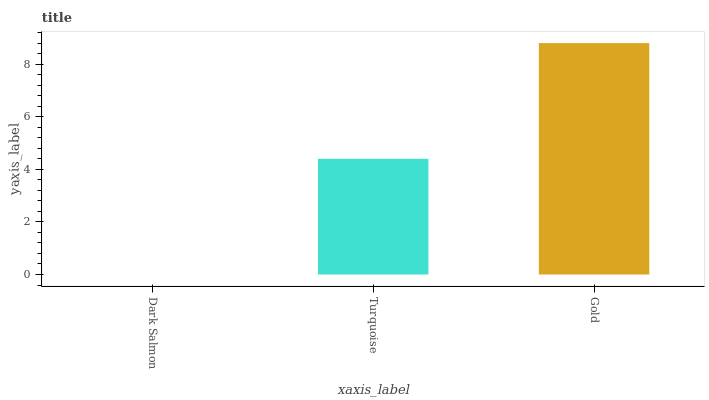Is Dark Salmon the minimum?
Answer yes or no. Yes. Is Gold the maximum?
Answer yes or no. Yes. Is Turquoise the minimum?
Answer yes or no. No. Is Turquoise the maximum?
Answer yes or no. No. Is Turquoise greater than Dark Salmon?
Answer yes or no. Yes. Is Dark Salmon less than Turquoise?
Answer yes or no. Yes. Is Dark Salmon greater than Turquoise?
Answer yes or no. No. Is Turquoise less than Dark Salmon?
Answer yes or no. No. Is Turquoise the high median?
Answer yes or no. Yes. Is Turquoise the low median?
Answer yes or no. Yes. Is Gold the high median?
Answer yes or no. No. Is Gold the low median?
Answer yes or no. No. 